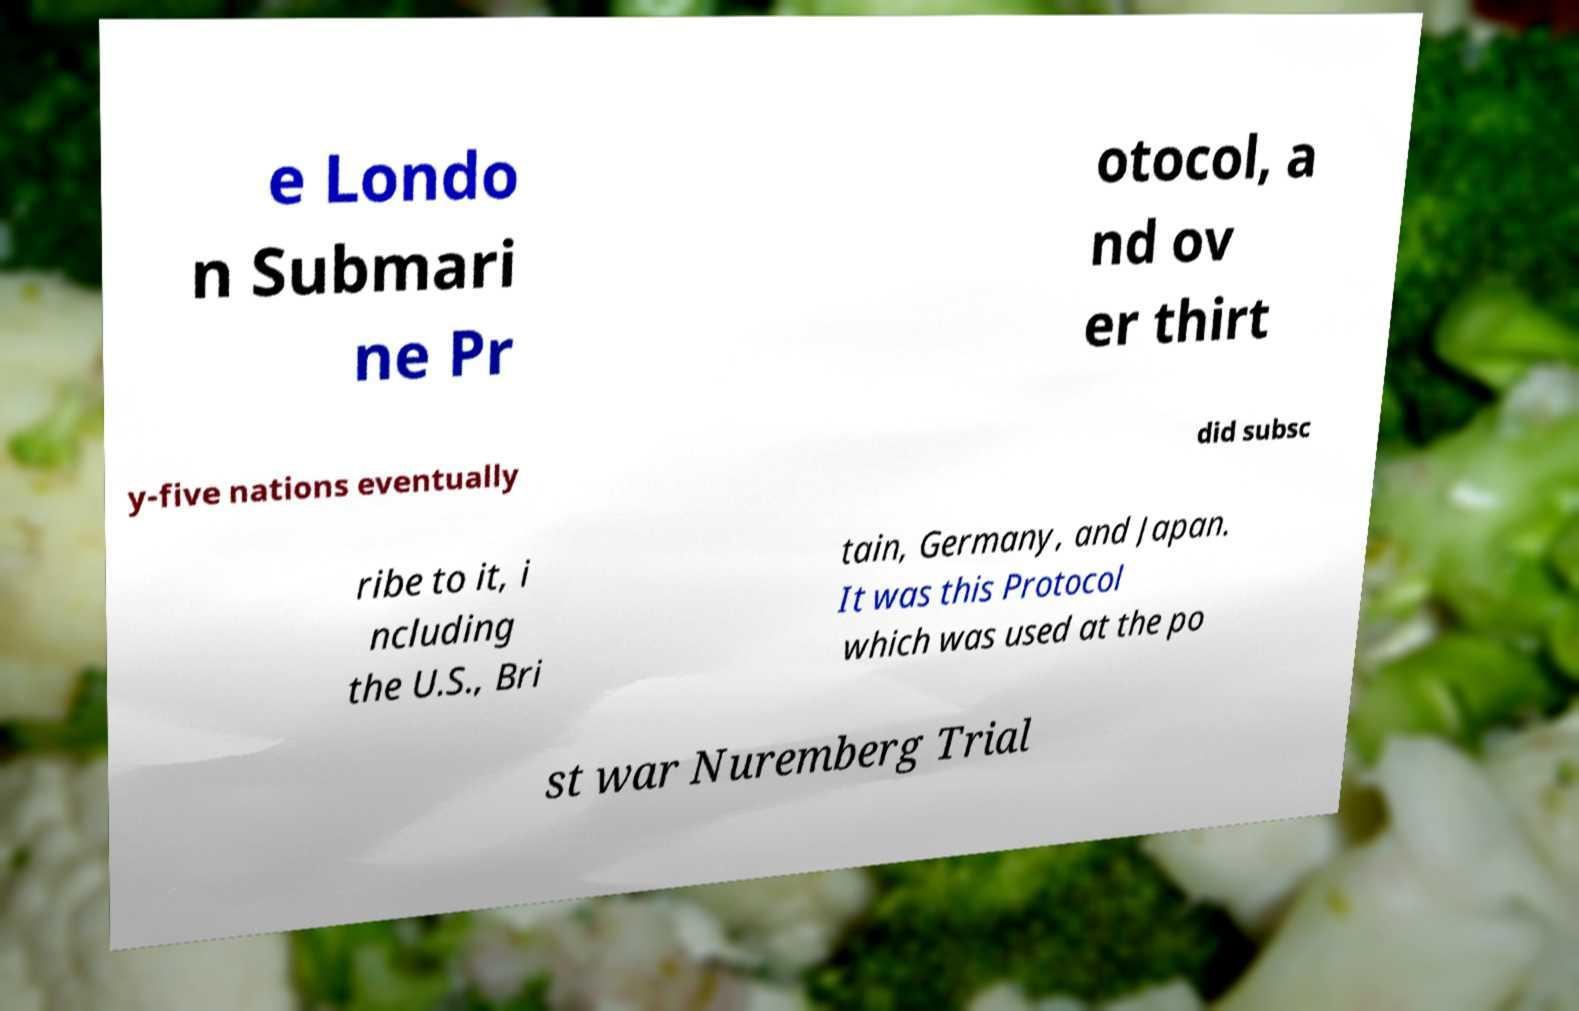Please identify and transcribe the text found in this image. e Londo n Submari ne Pr otocol, a nd ov er thirt y-five nations eventually did subsc ribe to it, i ncluding the U.S., Bri tain, Germany, and Japan. It was this Protocol which was used at the po st war Nuremberg Trial 